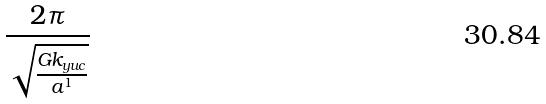Convert formula to latex. <formula><loc_0><loc_0><loc_500><loc_500>\frac { 2 \pi } { \sqrt { \frac { G k _ { y u c } } { a ^ { 1 } } } }</formula> 